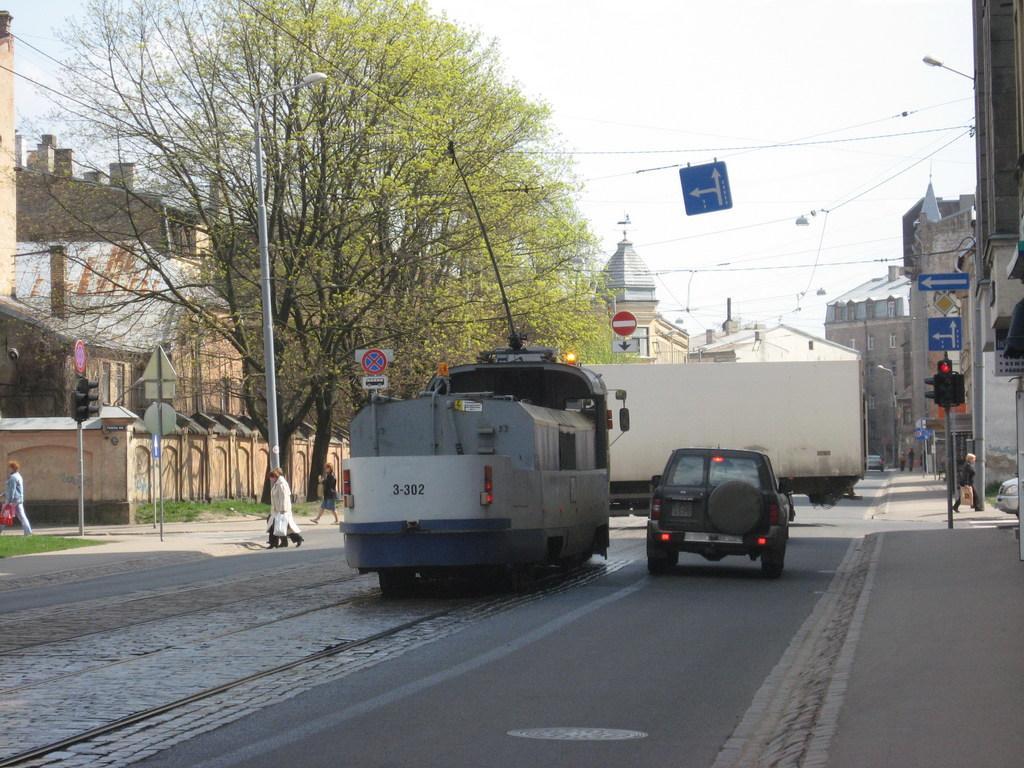Could you give a brief overview of what you see in this image? In the center of the image there are vehicles on the road. On both right and left side of the image there are people walking on the road. There are signal lights. There are directional boards, street lights. In the background of the image there are buildings, trees and sky. 